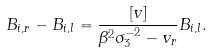Convert formula to latex. <formula><loc_0><loc_0><loc_500><loc_500>B _ { i , r } - B _ { i , l } = \frac { [ v ] } { \beta ^ { 2 } \sigma _ { 3 } ^ { - 2 } - v _ { r } } B _ { i , l } .</formula> 